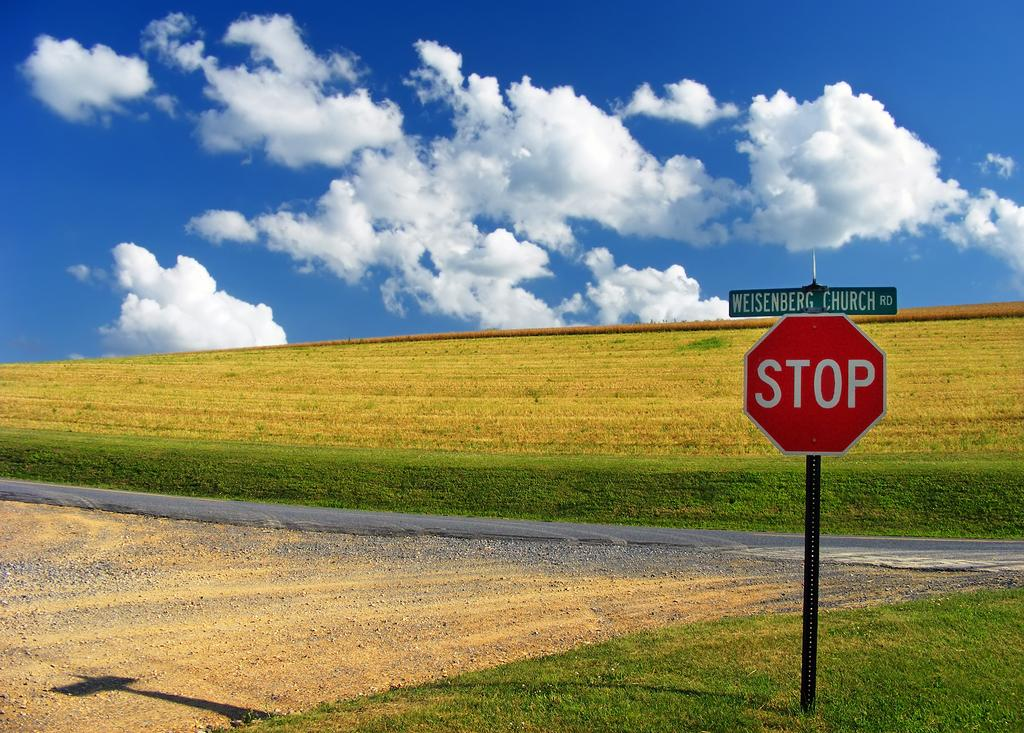Provide a one-sentence caption for the provided image. An open field with a blue sky and a stop sign on Church road. 